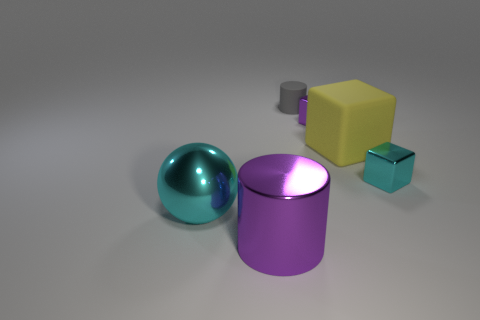Add 3 purple metallic cylinders. How many objects exist? 9 Subtract all tiny metal cubes. How many cubes are left? 1 Subtract all balls. How many objects are left? 5 Subtract all green blocks. Subtract all brown balls. How many blocks are left? 3 Subtract all large red metallic balls. Subtract all purple objects. How many objects are left? 4 Add 3 blocks. How many blocks are left? 6 Add 3 rubber things. How many rubber things exist? 5 Subtract all gray cylinders. How many cylinders are left? 1 Subtract 0 green cylinders. How many objects are left? 6 